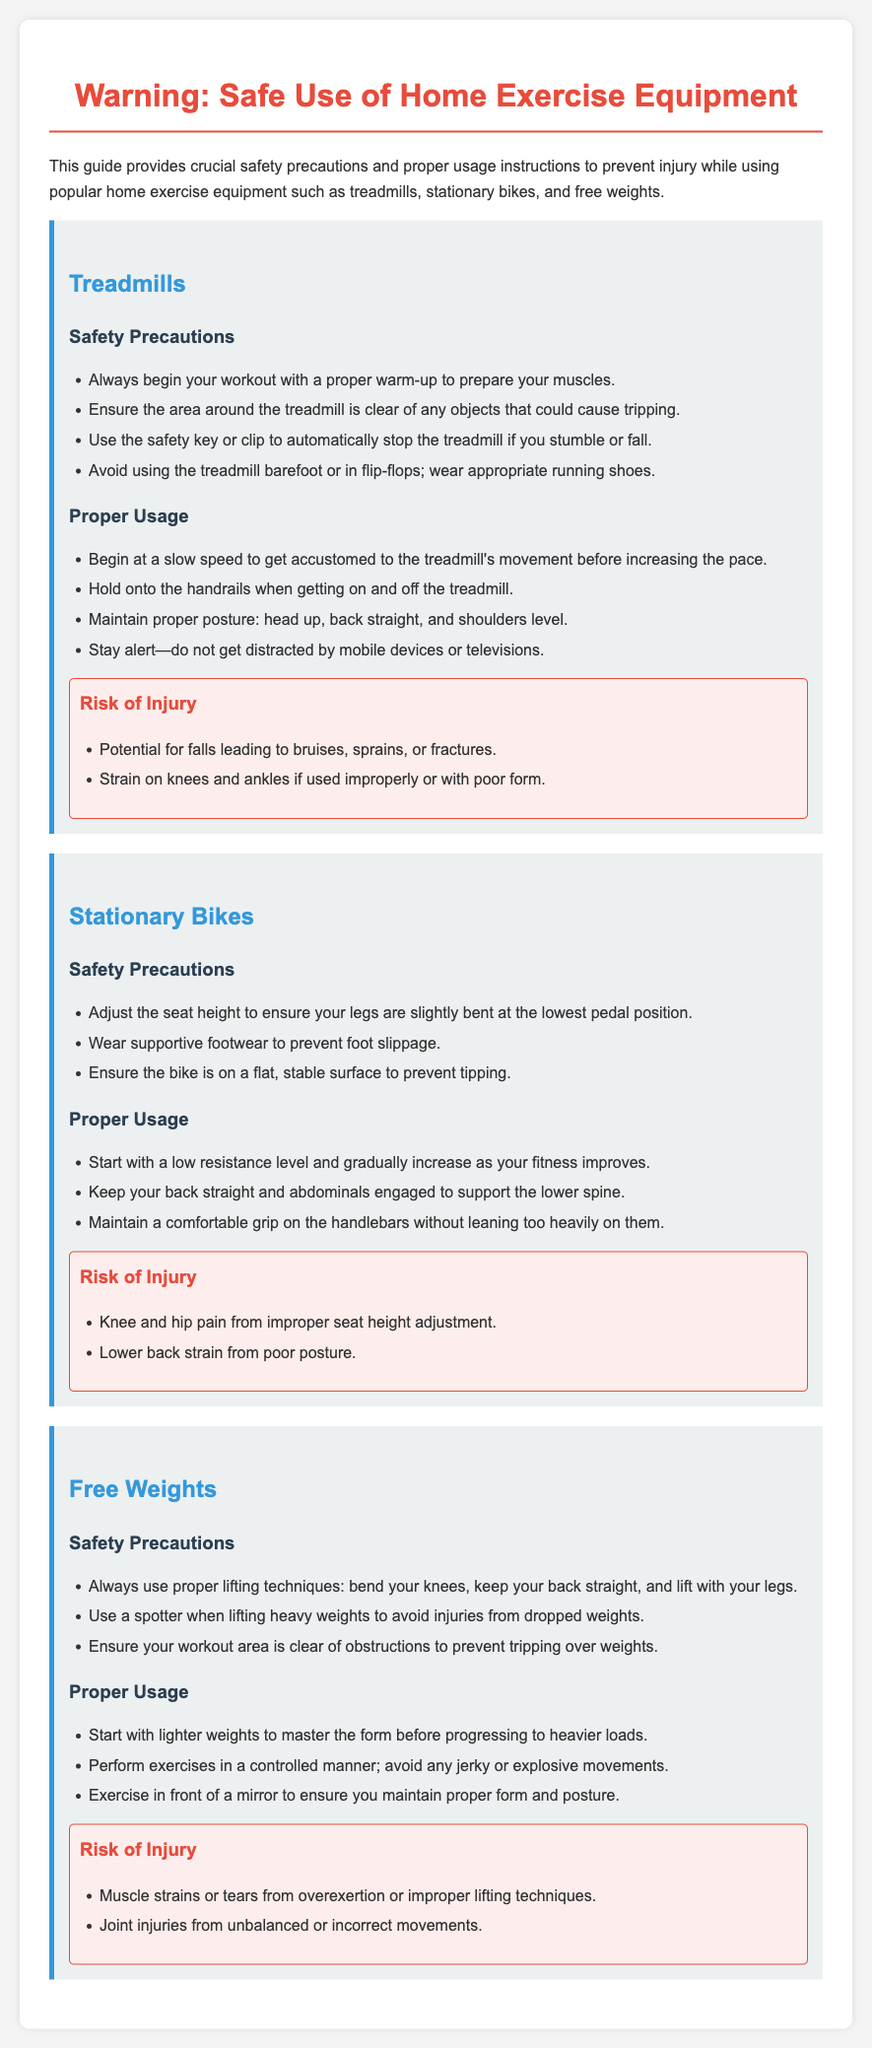What should you wear when using a treadmill? The document specifies that one should wear appropriate running shoes and avoid barefoot or flip-flops.
Answer: appropriate running shoes What is a critical safety feature on a treadmill? The safety key or clip automatically stops the treadmill if you stumble or fall.
Answer: safety key or clip What is the main risk associated with improper usage of free weights? The document states that muscle strains or tears can occur from overexertion or improper lifting techniques.
Answer: muscle strains or tears How should you adjust a stationary bike before use? The document mentions adjusting the seat height to ensure your legs are slightly bent at the lowest pedal position.
Answer: seat height What posture should you maintain while using a stationary bike? It highlights the importance of keeping your back straight and abdominals engaged to support the lower spine.
Answer: back straight What safety precaution involves your workout area for free weights? The guideline emphasizes ensuring your workout area is clear of obstructions to prevent tripping over weights.
Answer: clear of obstructions How can you avoid falls while using a treadmill? Hold onto the handrails when getting on and off the treadmill to prevent falls.
Answer: hold onto the handrails What should you do to prepare your muscles before using any equipment? The document advises beginning your workout with a proper warm-up.
Answer: proper warm-up What is advised to prevent knee pain when using a stationary bike? Adjusting the seat height properly is crucial to prevent knee and hip pain.
Answer: seat height adjustment 